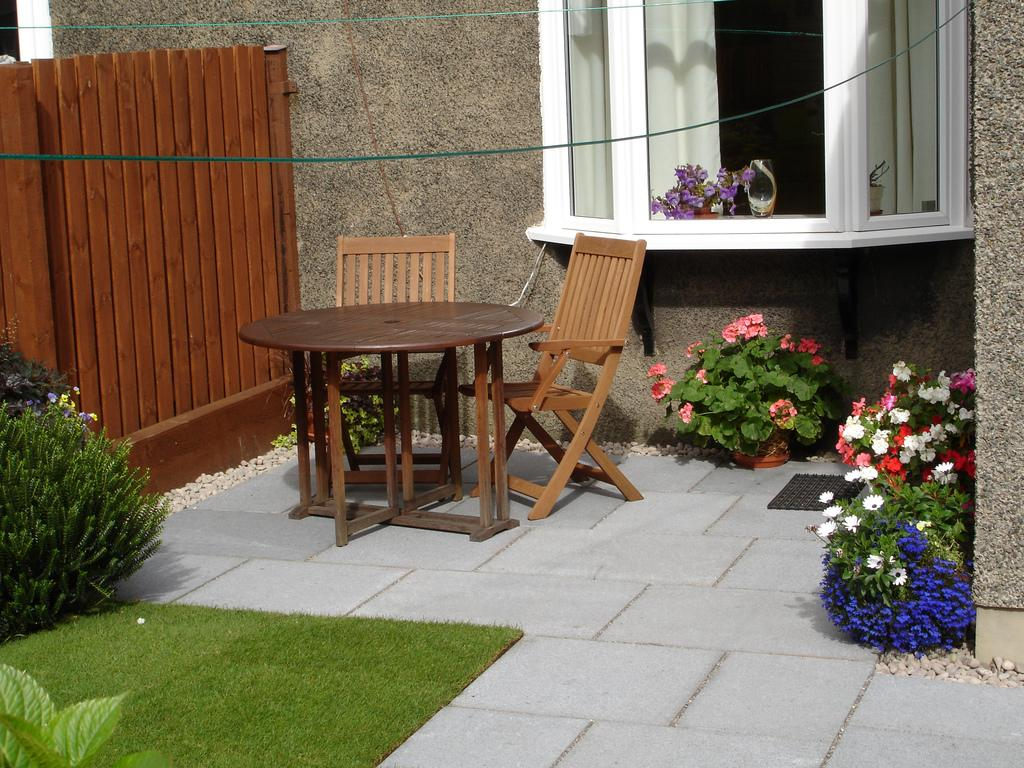What type of furniture is present in the image? There is a chair and a table in the image. What can be seen growing in the image? There are plants and flowers in the image. What architectural feature is visible in the image? There is a wall in the image. What is a source of natural light in the image? There is a window in the image. What type of window treatment is present in the image? There are curtains associated with the window. Can you tell me how many pots are on the table in the image? There is no pot present on the table in the image. Is there a stranger in the image? There is no stranger present in the image. 